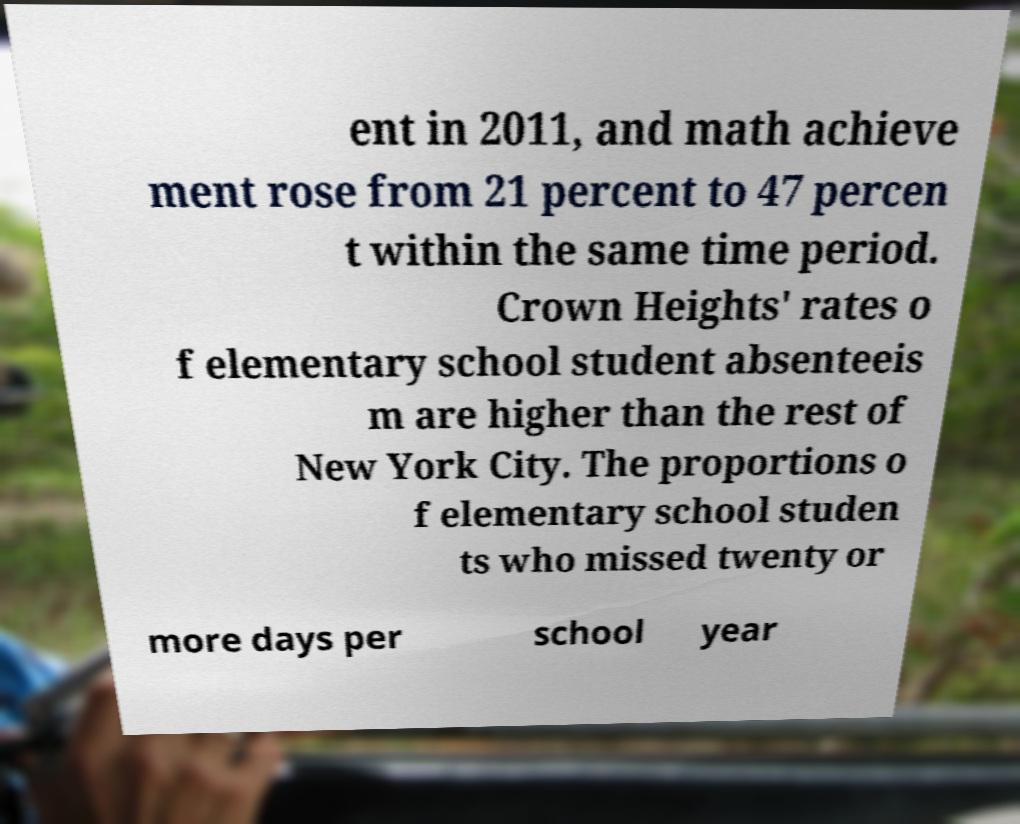For documentation purposes, I need the text within this image transcribed. Could you provide that? ent in 2011, and math achieve ment rose from 21 percent to 47 percen t within the same time period. Crown Heights' rates o f elementary school student absenteeis m are higher than the rest of New York City. The proportions o f elementary school studen ts who missed twenty or more days per school year 